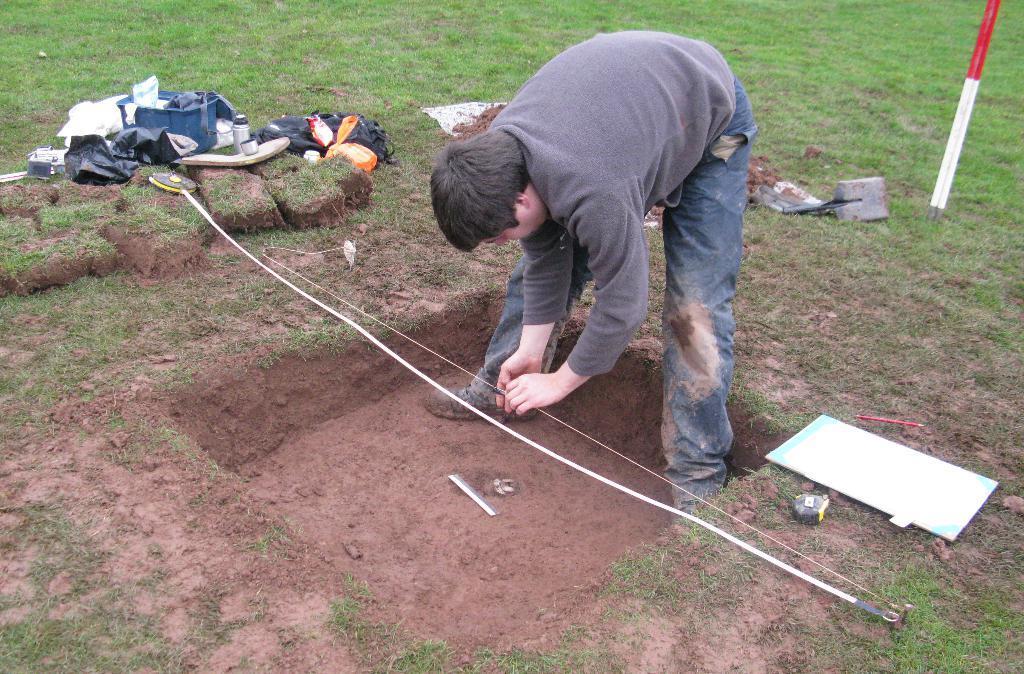Please provide a concise description of this image. In this image there is a person standing on the ground and measuring the length with the measuring tape. In the background there is a bottle, bag, cover, food packet, black covers and blue color container. Image also has pole, pen and also bricks, There is also a measuring tape in this image. 